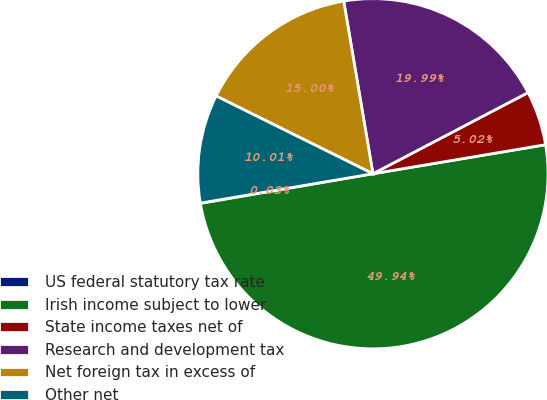Convert chart. <chart><loc_0><loc_0><loc_500><loc_500><pie_chart><fcel>US federal statutory tax rate<fcel>Irish income subject to lower<fcel>State income taxes net of<fcel>Research and development tax<fcel>Net foreign tax in excess of<fcel>Other net<nl><fcel>0.03%<fcel>49.93%<fcel>5.02%<fcel>19.99%<fcel>15.0%<fcel>10.01%<nl></chart> 